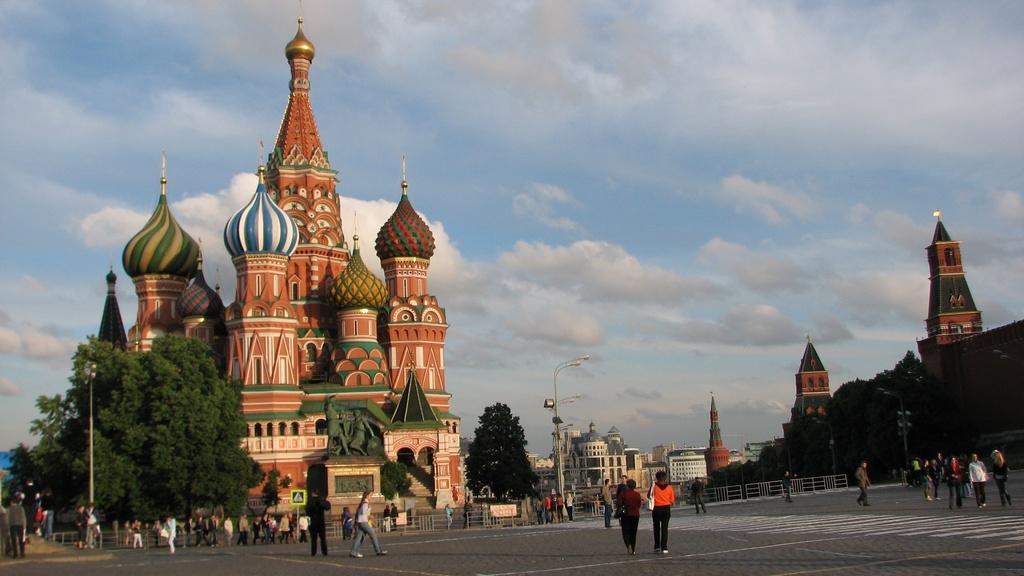In one or two sentences, can you explain what this image depicts? In this image there are buildings. There are trees. There is a statue in the left middle in front of the building. There are street lights. There are people on the roads. There is a road. There are clouds in the sky. 